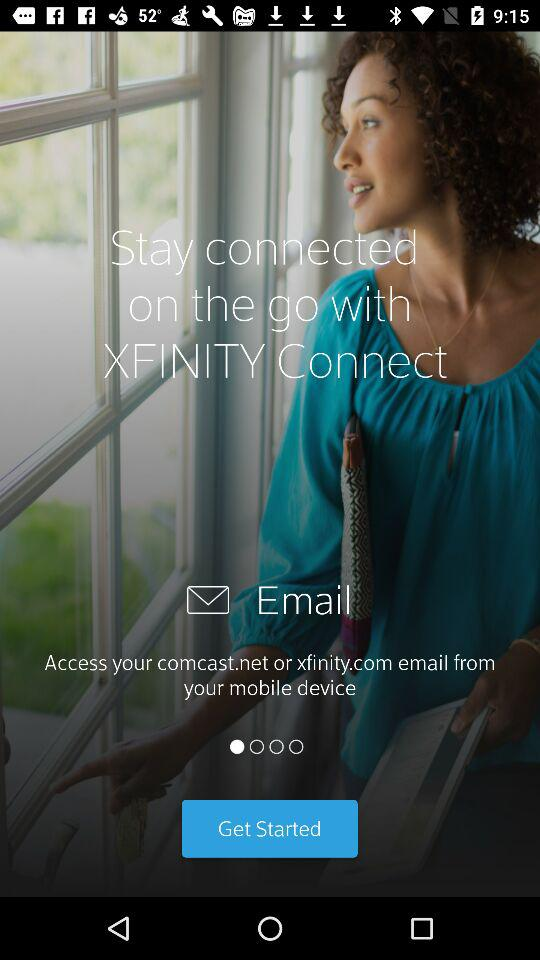What is the email address of the user?
When the provided information is insufficient, respond with <no answer>. <no answer> 